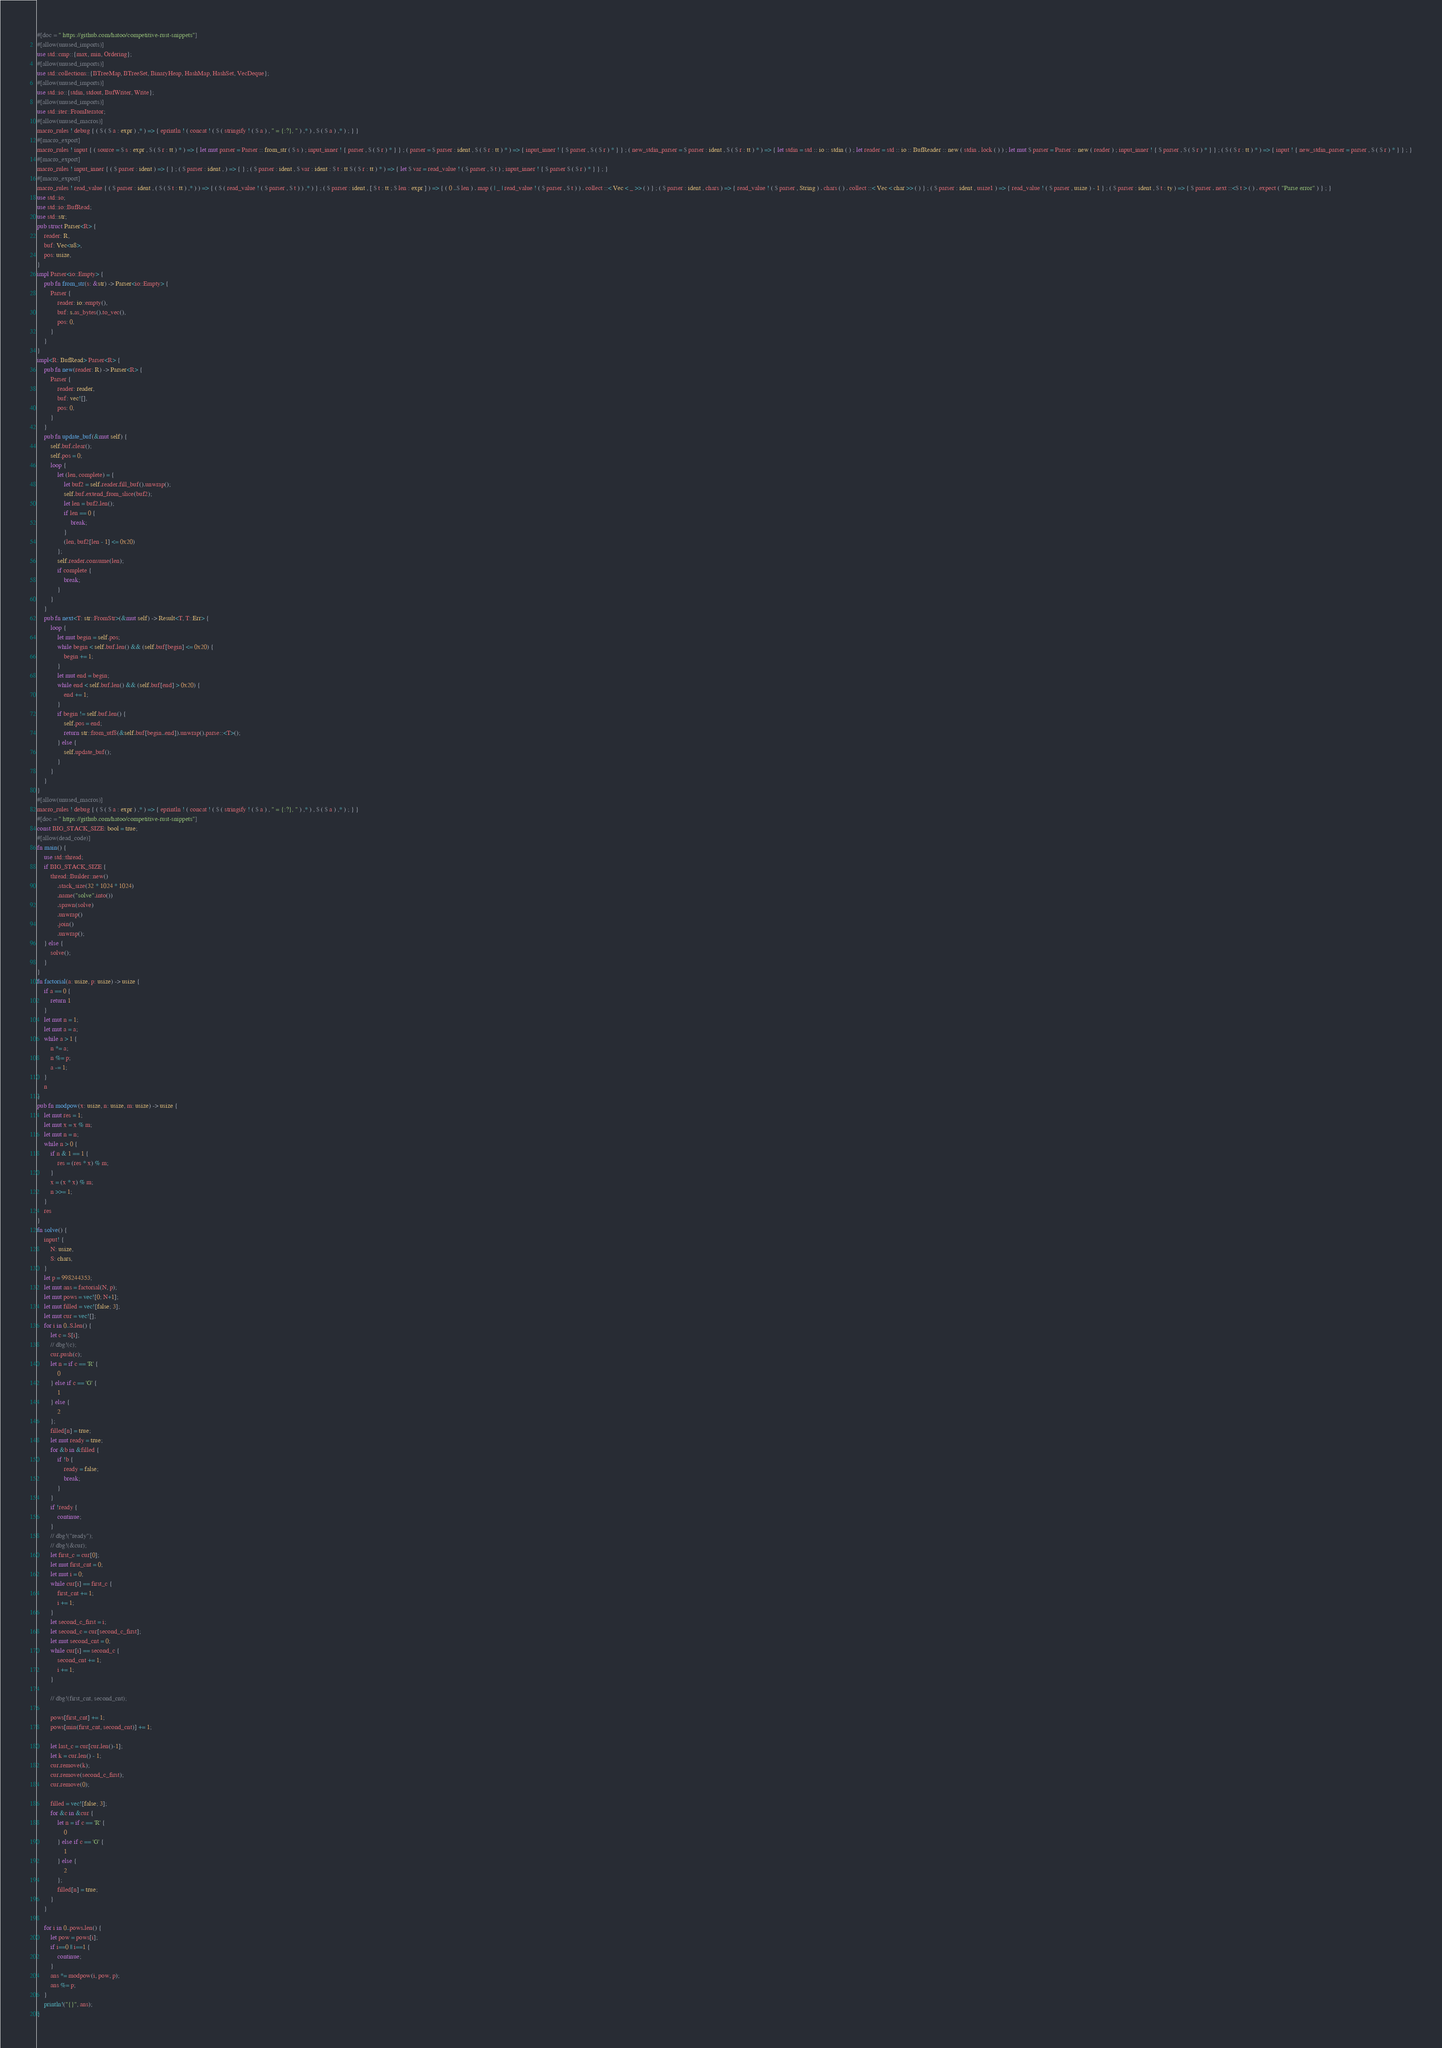Convert code to text. <code><loc_0><loc_0><loc_500><loc_500><_Rust_>#[doc = " https://github.com/hatoo/competitive-rust-snippets"]
#[allow(unused_imports)]
use std::cmp::{max, min, Ordering};
#[allow(unused_imports)]
use std::collections::{BTreeMap, BTreeSet, BinaryHeap, HashMap, HashSet, VecDeque};
#[allow(unused_imports)]
use std::io::{stdin, stdout, BufWriter, Write};
#[allow(unused_imports)]
use std::iter::FromIterator;
#[allow(unused_macros)]
macro_rules ! debug { ( $ ( $ a : expr ) ,* ) => { eprintln ! ( concat ! ( $ ( stringify ! ( $ a ) , " = {:?}, " ) ,* ) , $ ( $ a ) ,* ) ; } }
#[macro_export]
macro_rules ! input { ( source = $ s : expr , $ ( $ r : tt ) * ) => { let mut parser = Parser :: from_str ( $ s ) ; input_inner ! { parser , $ ( $ r ) * } } ; ( parser = $ parser : ident , $ ( $ r : tt ) * ) => { input_inner ! { $ parser , $ ( $ r ) * } } ; ( new_stdin_parser = $ parser : ident , $ ( $ r : tt ) * ) => { let stdin = std :: io :: stdin ( ) ; let reader = std :: io :: BufReader :: new ( stdin . lock ( ) ) ; let mut $ parser = Parser :: new ( reader ) ; input_inner ! { $ parser , $ ( $ r ) * } } ; ( $ ( $ r : tt ) * ) => { input ! { new_stdin_parser = parser , $ ( $ r ) * } } ; }
#[macro_export]
macro_rules ! input_inner { ( $ parser : ident ) => { } ; ( $ parser : ident , ) => { } ; ( $ parser : ident , $ var : ident : $ t : tt $ ( $ r : tt ) * ) => { let $ var = read_value ! ( $ parser , $ t ) ; input_inner ! { $ parser $ ( $ r ) * } } ; }
#[macro_export]
macro_rules ! read_value { ( $ parser : ident , ( $ ( $ t : tt ) ,* ) ) => { ( $ ( read_value ! ( $ parser , $ t ) ) ,* ) } ; ( $ parser : ident , [ $ t : tt ; $ len : expr ] ) => { ( 0 ..$ len ) . map ( | _ | read_value ! ( $ parser , $ t ) ) . collect ::< Vec < _ >> ( ) } ; ( $ parser : ident , chars ) => { read_value ! ( $ parser , String ) . chars ( ) . collect ::< Vec < char >> ( ) } ; ( $ parser : ident , usize1 ) => { read_value ! ( $ parser , usize ) - 1 } ; ( $ parser : ident , $ t : ty ) => { $ parser . next ::<$ t > ( ) . expect ( "Parse error" ) } ; }
use std::io;
use std::io::BufRead;
use std::str;
pub struct Parser<R> {
    reader: R,
    buf: Vec<u8>,
    pos: usize,
}
impl Parser<io::Empty> {
    pub fn from_str(s: &str) -> Parser<io::Empty> {
        Parser {
            reader: io::empty(),
            buf: s.as_bytes().to_vec(),
            pos: 0,
        }
    }
}
impl<R: BufRead> Parser<R> {
    pub fn new(reader: R) -> Parser<R> {
        Parser {
            reader: reader,
            buf: vec![],
            pos: 0,
        }
    }
    pub fn update_buf(&mut self) {
        self.buf.clear();
        self.pos = 0;
        loop {
            let (len, complete) = {
                let buf2 = self.reader.fill_buf().unwrap();
                self.buf.extend_from_slice(buf2);
                let len = buf2.len();
                if len == 0 {
                    break;
                }
                (len, buf2[len - 1] <= 0x20)
            };
            self.reader.consume(len);
            if complete {
                break;
            }
        }
    }
    pub fn next<T: str::FromStr>(&mut self) -> Result<T, T::Err> {
        loop {
            let mut begin = self.pos;
            while begin < self.buf.len() && (self.buf[begin] <= 0x20) {
                begin += 1;
            }
            let mut end = begin;
            while end < self.buf.len() && (self.buf[end] > 0x20) {
                end += 1;
            }
            if begin != self.buf.len() {
                self.pos = end;
                return str::from_utf8(&self.buf[begin..end]).unwrap().parse::<T>();
            } else {
                self.update_buf();
            }
        }
    }
}
#[allow(unused_macros)]
macro_rules ! debug { ( $ ( $ a : expr ) ,* ) => { eprintln ! ( concat ! ( $ ( stringify ! ( $ a ) , " = {:?}, " ) ,* ) , $ ( $ a ) ,* ) ; } }
#[doc = " https://github.com/hatoo/competitive-rust-snippets"]
const BIG_STACK_SIZE: bool = true;
#[allow(dead_code)]
fn main() {
    use std::thread;
    if BIG_STACK_SIZE {
        thread::Builder::new()
            .stack_size(32 * 1024 * 1024)
            .name("solve".into())
            .spawn(solve)
            .unwrap()
            .join()
            .unwrap();
    } else {
        solve();
    }
}
fn factorial(a: usize, p: usize) -> usize {
    if a == 0 {
        return 1
    }
    let mut n = 1;
    let mut a = a;
    while a > 1 {
        n *= a;
        n %= p;
        a -= 1;
    }
    n
}
pub fn modpow(x: usize, n: usize, m: usize) -> usize {
    let mut res = 1;
    let mut x = x % m;
    let mut n = n;
    while n > 0 {
        if n & 1 == 1 {
            res = (res * x) % m;
        }
        x = (x * x) % m;
        n >>= 1;
    }
    res
}
fn solve() {
    input! {
        N: usize,
        S: chars,
    }
    let p = 998244353;
    let mut ans = factorial(N, p);
    let mut pows = vec![0; N+1];
    let mut filled = vec![false; 3];
    let mut cur = vec![];
    for i in 0..S.len() {
        let c = S[i];
        // dbg!(c);
        cur.push(c);
        let n = if c == 'R' {
            0
        } else if c == 'G' {
            1
        } else {
            2
        };
        filled[n] = true;
        let mut ready = true;
        for &b in &filled {
            if !b {
                ready = false;
                break;
            }
        }
        if !ready {
            continue;
        }
        // dbg!("ready");
        // dbg!(&cur);
        let first_c = cur[0];
        let mut first_cnt = 0;
        let mut i = 0;
        while cur[i] == first_c {
            first_cnt += 1;
            i += 1;
        }
        let second_c_first = i;
        let second_c = cur[second_c_first];
        let mut second_cnt = 0;
        while cur[i] == second_c {
            second_cnt += 1;
            i += 1;
        }

        // dbg!(first_cnt, second_cnt);

        pows[first_cnt] += 1;
        pows[min(first_cnt, second_cnt)] += 1;
        
        let last_c = cur[cur.len()-1];
        let k = cur.len() - 1;
        cur.remove(k);
        cur.remove(second_c_first);
        cur.remove(0);

        filled = vec![false; 3];
        for &c in &cur {
            let n = if c == 'R' {
                0
            } else if c == 'G' {
                1
            } else {
                2
            };
            filled[n] = true;
        }
    }

    for i in 0..pows.len() {
        let pow = pows[i];
        if i==0 || i==1 {
            continue;
        }
        ans *= modpow(i, pow, p);
        ans %= p;
    }
    println!("{}", ans);
}</code> 